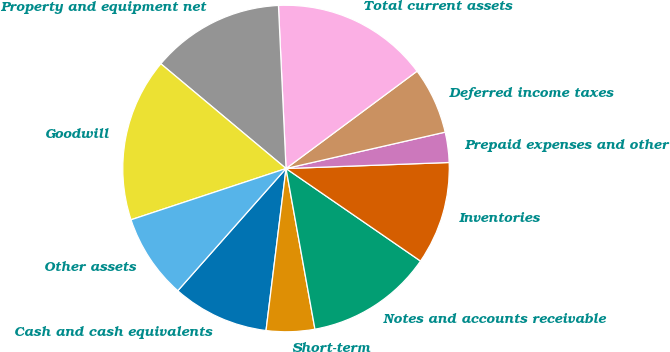<chart> <loc_0><loc_0><loc_500><loc_500><pie_chart><fcel>Cash and cash equivalents<fcel>Short-term<fcel>Notes and accounts receivable<fcel>Inventories<fcel>Prepaid expenses and other<fcel>Deferred income taxes<fcel>Total current assets<fcel>Property and equipment net<fcel>Goodwill<fcel>Other assets<nl><fcel>9.58%<fcel>4.79%<fcel>12.57%<fcel>10.18%<fcel>2.99%<fcel>6.59%<fcel>15.57%<fcel>13.17%<fcel>16.17%<fcel>8.38%<nl></chart> 